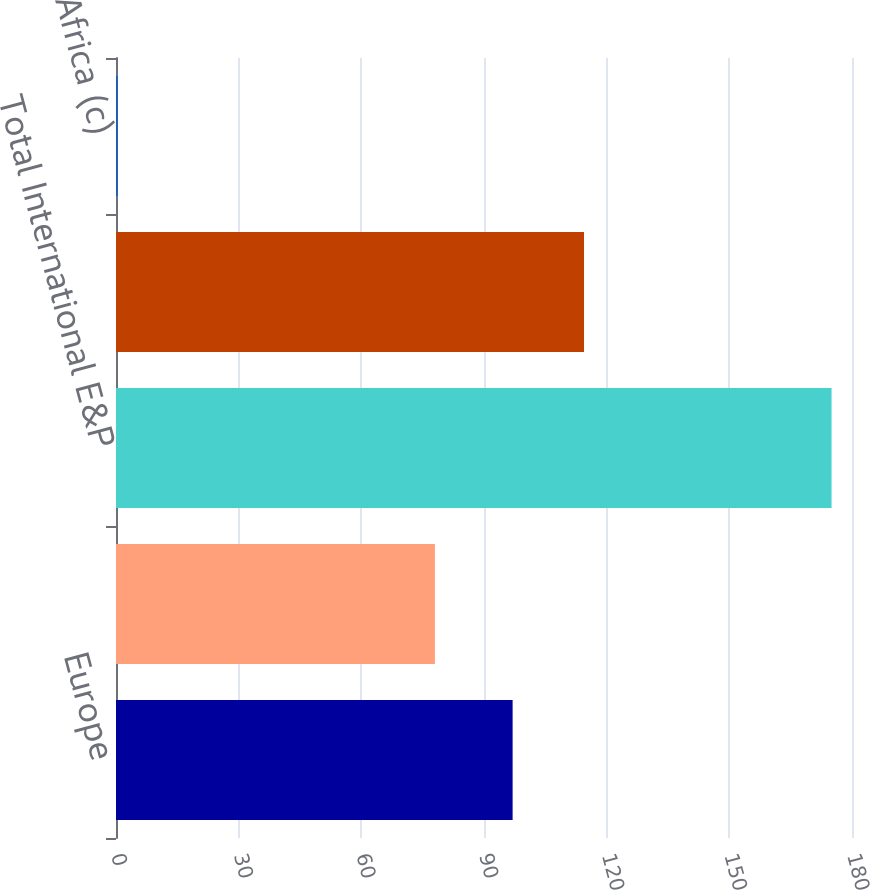Convert chart. <chart><loc_0><loc_0><loc_500><loc_500><bar_chart><fcel>Europe<fcel>Africa<fcel>Total International E&P<fcel>Europe (b)<fcel>Africa (c)<nl><fcel>97<fcel>78<fcel>175<fcel>114.46<fcel>0.43<nl></chart> 